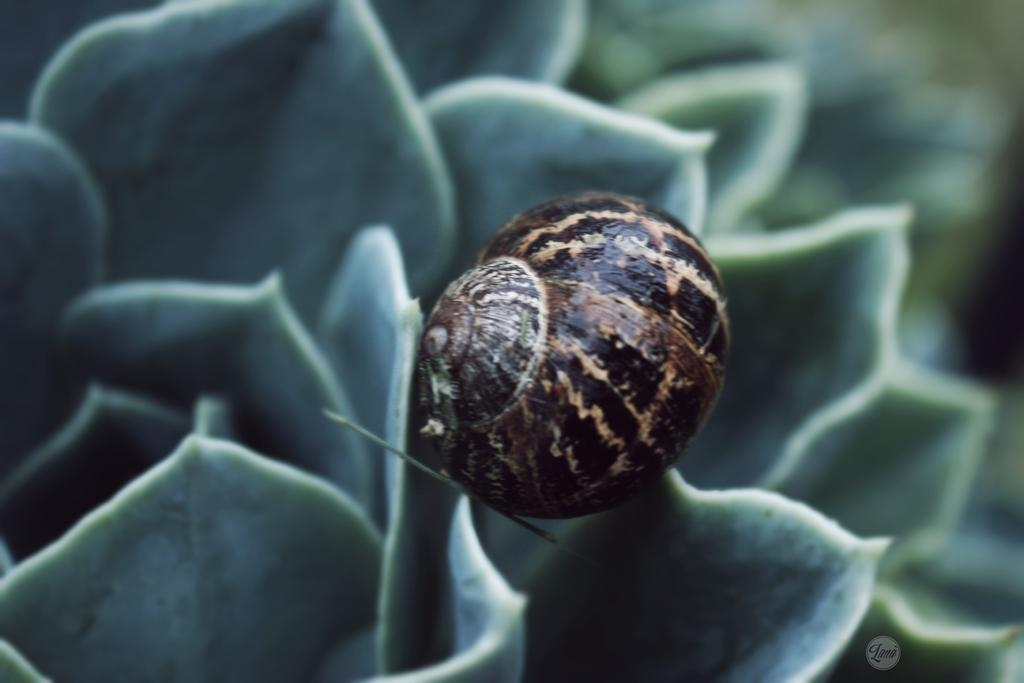What is the main subject in the center of the image? There is a flower in the center of the image. Is there anything else present on the flower? Yes, there is an insect on the flower. How does the flower control the traffic in the image? The flower does not control traffic in the image; it is a natural object and not involved in traffic control. 